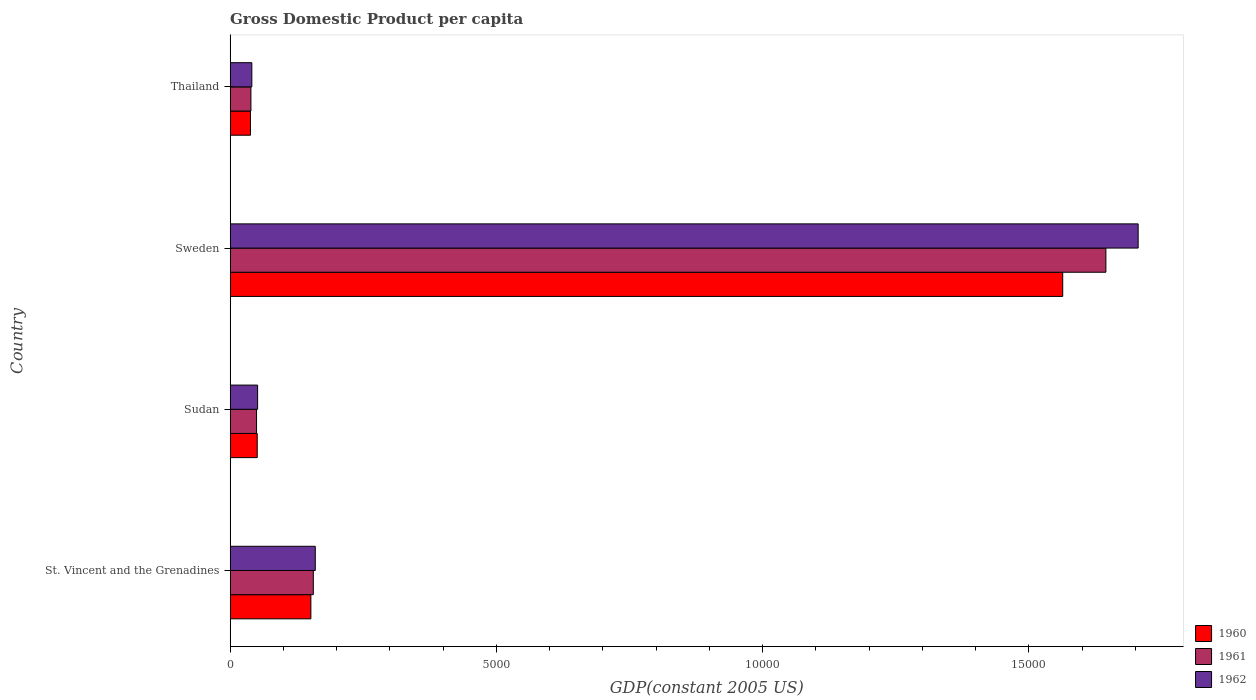How many groups of bars are there?
Give a very brief answer. 4. Are the number of bars per tick equal to the number of legend labels?
Your answer should be very brief. Yes. How many bars are there on the 1st tick from the top?
Keep it short and to the point. 3. How many bars are there on the 1st tick from the bottom?
Offer a terse response. 3. What is the label of the 2nd group of bars from the top?
Make the answer very short. Sweden. In how many cases, is the number of bars for a given country not equal to the number of legend labels?
Keep it short and to the point. 0. What is the GDP per capita in 1960 in Sweden?
Provide a short and direct response. 1.56e+04. Across all countries, what is the maximum GDP per capita in 1962?
Provide a short and direct response. 1.71e+04. Across all countries, what is the minimum GDP per capita in 1962?
Your answer should be very brief. 406.6. In which country was the GDP per capita in 1960 minimum?
Offer a terse response. Thailand. What is the total GDP per capita in 1962 in the graph?
Offer a very short reply. 1.96e+04. What is the difference between the GDP per capita in 1961 in Sudan and that in Sweden?
Offer a very short reply. -1.60e+04. What is the difference between the GDP per capita in 1960 in Thailand and the GDP per capita in 1961 in Sweden?
Make the answer very short. -1.61e+04. What is the average GDP per capita in 1961 per country?
Keep it short and to the point. 4722.79. What is the difference between the GDP per capita in 1961 and GDP per capita in 1962 in Sweden?
Your response must be concise. -606.08. What is the ratio of the GDP per capita in 1960 in Sudan to that in Thailand?
Your answer should be compact. 1.33. What is the difference between the highest and the second highest GDP per capita in 1961?
Provide a short and direct response. 1.49e+04. What is the difference between the highest and the lowest GDP per capita in 1960?
Offer a terse response. 1.53e+04. In how many countries, is the GDP per capita in 1962 greater than the average GDP per capita in 1962 taken over all countries?
Make the answer very short. 1. Is the sum of the GDP per capita in 1962 in Sudan and Thailand greater than the maximum GDP per capita in 1960 across all countries?
Offer a terse response. No. What does the 1st bar from the bottom in St. Vincent and the Grenadines represents?
Your answer should be very brief. 1960. Is it the case that in every country, the sum of the GDP per capita in 1962 and GDP per capita in 1960 is greater than the GDP per capita in 1961?
Offer a terse response. Yes. Does the graph contain any zero values?
Offer a very short reply. No. How are the legend labels stacked?
Ensure brevity in your answer.  Vertical. What is the title of the graph?
Provide a short and direct response. Gross Domestic Product per capita. Does "1996" appear as one of the legend labels in the graph?
Your response must be concise. No. What is the label or title of the X-axis?
Make the answer very short. GDP(constant 2005 US). What is the label or title of the Y-axis?
Your response must be concise. Country. What is the GDP(constant 2005 US) of 1960 in St. Vincent and the Grenadines?
Offer a very short reply. 1515.48. What is the GDP(constant 2005 US) of 1961 in St. Vincent and the Grenadines?
Keep it short and to the point. 1561.03. What is the GDP(constant 2005 US) of 1962 in St. Vincent and the Grenadines?
Your answer should be compact. 1598.04. What is the GDP(constant 2005 US) of 1960 in Sudan?
Your response must be concise. 507.97. What is the GDP(constant 2005 US) of 1961 in Sudan?
Keep it short and to the point. 494.94. What is the GDP(constant 2005 US) in 1962 in Sudan?
Provide a succinct answer. 515.24. What is the GDP(constant 2005 US) in 1960 in Sweden?
Your answer should be very brief. 1.56e+04. What is the GDP(constant 2005 US) of 1961 in Sweden?
Keep it short and to the point. 1.64e+04. What is the GDP(constant 2005 US) in 1962 in Sweden?
Provide a succinct answer. 1.71e+04. What is the GDP(constant 2005 US) of 1960 in Thailand?
Your answer should be compact. 380.85. What is the GDP(constant 2005 US) of 1961 in Thailand?
Your answer should be compact. 389.52. What is the GDP(constant 2005 US) of 1962 in Thailand?
Your answer should be compact. 406.6. Across all countries, what is the maximum GDP(constant 2005 US) of 1960?
Offer a very short reply. 1.56e+04. Across all countries, what is the maximum GDP(constant 2005 US) of 1961?
Offer a terse response. 1.64e+04. Across all countries, what is the maximum GDP(constant 2005 US) in 1962?
Provide a succinct answer. 1.71e+04. Across all countries, what is the minimum GDP(constant 2005 US) of 1960?
Provide a succinct answer. 380.85. Across all countries, what is the minimum GDP(constant 2005 US) of 1961?
Give a very brief answer. 389.52. Across all countries, what is the minimum GDP(constant 2005 US) in 1962?
Your answer should be very brief. 406.6. What is the total GDP(constant 2005 US) in 1960 in the graph?
Ensure brevity in your answer.  1.80e+04. What is the total GDP(constant 2005 US) in 1961 in the graph?
Make the answer very short. 1.89e+04. What is the total GDP(constant 2005 US) of 1962 in the graph?
Offer a very short reply. 1.96e+04. What is the difference between the GDP(constant 2005 US) of 1960 in St. Vincent and the Grenadines and that in Sudan?
Provide a succinct answer. 1007.51. What is the difference between the GDP(constant 2005 US) in 1961 in St. Vincent and the Grenadines and that in Sudan?
Provide a succinct answer. 1066.09. What is the difference between the GDP(constant 2005 US) in 1962 in St. Vincent and the Grenadines and that in Sudan?
Your answer should be compact. 1082.79. What is the difference between the GDP(constant 2005 US) in 1960 in St. Vincent and the Grenadines and that in Sweden?
Your answer should be compact. -1.41e+04. What is the difference between the GDP(constant 2005 US) in 1961 in St. Vincent and the Grenadines and that in Sweden?
Make the answer very short. -1.49e+04. What is the difference between the GDP(constant 2005 US) of 1962 in St. Vincent and the Grenadines and that in Sweden?
Keep it short and to the point. -1.55e+04. What is the difference between the GDP(constant 2005 US) of 1960 in St. Vincent and the Grenadines and that in Thailand?
Offer a very short reply. 1134.63. What is the difference between the GDP(constant 2005 US) of 1961 in St. Vincent and the Grenadines and that in Thailand?
Your answer should be very brief. 1171.51. What is the difference between the GDP(constant 2005 US) in 1962 in St. Vincent and the Grenadines and that in Thailand?
Provide a short and direct response. 1191.44. What is the difference between the GDP(constant 2005 US) in 1960 in Sudan and that in Sweden?
Your answer should be very brief. -1.51e+04. What is the difference between the GDP(constant 2005 US) of 1961 in Sudan and that in Sweden?
Provide a short and direct response. -1.60e+04. What is the difference between the GDP(constant 2005 US) in 1962 in Sudan and that in Sweden?
Ensure brevity in your answer.  -1.65e+04. What is the difference between the GDP(constant 2005 US) of 1960 in Sudan and that in Thailand?
Offer a very short reply. 127.12. What is the difference between the GDP(constant 2005 US) of 1961 in Sudan and that in Thailand?
Provide a succinct answer. 105.42. What is the difference between the GDP(constant 2005 US) in 1962 in Sudan and that in Thailand?
Offer a very short reply. 108.64. What is the difference between the GDP(constant 2005 US) in 1960 in Sweden and that in Thailand?
Provide a succinct answer. 1.53e+04. What is the difference between the GDP(constant 2005 US) in 1961 in Sweden and that in Thailand?
Your response must be concise. 1.61e+04. What is the difference between the GDP(constant 2005 US) of 1962 in Sweden and that in Thailand?
Provide a short and direct response. 1.66e+04. What is the difference between the GDP(constant 2005 US) of 1960 in St. Vincent and the Grenadines and the GDP(constant 2005 US) of 1961 in Sudan?
Provide a short and direct response. 1020.54. What is the difference between the GDP(constant 2005 US) in 1960 in St. Vincent and the Grenadines and the GDP(constant 2005 US) in 1962 in Sudan?
Give a very brief answer. 1000.24. What is the difference between the GDP(constant 2005 US) of 1961 in St. Vincent and the Grenadines and the GDP(constant 2005 US) of 1962 in Sudan?
Ensure brevity in your answer.  1045.78. What is the difference between the GDP(constant 2005 US) of 1960 in St. Vincent and the Grenadines and the GDP(constant 2005 US) of 1961 in Sweden?
Offer a very short reply. -1.49e+04. What is the difference between the GDP(constant 2005 US) of 1960 in St. Vincent and the Grenadines and the GDP(constant 2005 US) of 1962 in Sweden?
Keep it short and to the point. -1.55e+04. What is the difference between the GDP(constant 2005 US) of 1961 in St. Vincent and the Grenadines and the GDP(constant 2005 US) of 1962 in Sweden?
Your answer should be compact. -1.55e+04. What is the difference between the GDP(constant 2005 US) in 1960 in St. Vincent and the Grenadines and the GDP(constant 2005 US) in 1961 in Thailand?
Provide a short and direct response. 1125.96. What is the difference between the GDP(constant 2005 US) in 1960 in St. Vincent and the Grenadines and the GDP(constant 2005 US) in 1962 in Thailand?
Keep it short and to the point. 1108.88. What is the difference between the GDP(constant 2005 US) of 1961 in St. Vincent and the Grenadines and the GDP(constant 2005 US) of 1962 in Thailand?
Keep it short and to the point. 1154.43. What is the difference between the GDP(constant 2005 US) in 1960 in Sudan and the GDP(constant 2005 US) in 1961 in Sweden?
Give a very brief answer. -1.59e+04. What is the difference between the GDP(constant 2005 US) of 1960 in Sudan and the GDP(constant 2005 US) of 1962 in Sweden?
Your response must be concise. -1.65e+04. What is the difference between the GDP(constant 2005 US) of 1961 in Sudan and the GDP(constant 2005 US) of 1962 in Sweden?
Provide a succinct answer. -1.66e+04. What is the difference between the GDP(constant 2005 US) in 1960 in Sudan and the GDP(constant 2005 US) in 1961 in Thailand?
Offer a terse response. 118.46. What is the difference between the GDP(constant 2005 US) of 1960 in Sudan and the GDP(constant 2005 US) of 1962 in Thailand?
Offer a very short reply. 101.38. What is the difference between the GDP(constant 2005 US) in 1961 in Sudan and the GDP(constant 2005 US) in 1962 in Thailand?
Your answer should be very brief. 88.34. What is the difference between the GDP(constant 2005 US) in 1960 in Sweden and the GDP(constant 2005 US) in 1961 in Thailand?
Keep it short and to the point. 1.52e+04. What is the difference between the GDP(constant 2005 US) of 1960 in Sweden and the GDP(constant 2005 US) of 1962 in Thailand?
Offer a terse response. 1.52e+04. What is the difference between the GDP(constant 2005 US) of 1961 in Sweden and the GDP(constant 2005 US) of 1962 in Thailand?
Offer a terse response. 1.60e+04. What is the average GDP(constant 2005 US) in 1960 per country?
Give a very brief answer. 4509.84. What is the average GDP(constant 2005 US) in 1961 per country?
Offer a very short reply. 4722.79. What is the average GDP(constant 2005 US) in 1962 per country?
Your response must be concise. 4892.91. What is the difference between the GDP(constant 2005 US) in 1960 and GDP(constant 2005 US) in 1961 in St. Vincent and the Grenadines?
Your answer should be very brief. -45.55. What is the difference between the GDP(constant 2005 US) in 1960 and GDP(constant 2005 US) in 1962 in St. Vincent and the Grenadines?
Make the answer very short. -82.55. What is the difference between the GDP(constant 2005 US) of 1961 and GDP(constant 2005 US) of 1962 in St. Vincent and the Grenadines?
Offer a terse response. -37.01. What is the difference between the GDP(constant 2005 US) in 1960 and GDP(constant 2005 US) in 1961 in Sudan?
Provide a short and direct response. 13.04. What is the difference between the GDP(constant 2005 US) in 1960 and GDP(constant 2005 US) in 1962 in Sudan?
Make the answer very short. -7.27. What is the difference between the GDP(constant 2005 US) in 1961 and GDP(constant 2005 US) in 1962 in Sudan?
Provide a succinct answer. -20.31. What is the difference between the GDP(constant 2005 US) of 1960 and GDP(constant 2005 US) of 1961 in Sweden?
Give a very brief answer. -810.66. What is the difference between the GDP(constant 2005 US) of 1960 and GDP(constant 2005 US) of 1962 in Sweden?
Give a very brief answer. -1416.73. What is the difference between the GDP(constant 2005 US) in 1961 and GDP(constant 2005 US) in 1962 in Sweden?
Keep it short and to the point. -606.08. What is the difference between the GDP(constant 2005 US) in 1960 and GDP(constant 2005 US) in 1961 in Thailand?
Offer a terse response. -8.66. What is the difference between the GDP(constant 2005 US) in 1960 and GDP(constant 2005 US) in 1962 in Thailand?
Make the answer very short. -25.75. What is the difference between the GDP(constant 2005 US) in 1961 and GDP(constant 2005 US) in 1962 in Thailand?
Provide a succinct answer. -17.08. What is the ratio of the GDP(constant 2005 US) of 1960 in St. Vincent and the Grenadines to that in Sudan?
Your answer should be compact. 2.98. What is the ratio of the GDP(constant 2005 US) in 1961 in St. Vincent and the Grenadines to that in Sudan?
Provide a succinct answer. 3.15. What is the ratio of the GDP(constant 2005 US) in 1962 in St. Vincent and the Grenadines to that in Sudan?
Your response must be concise. 3.1. What is the ratio of the GDP(constant 2005 US) of 1960 in St. Vincent and the Grenadines to that in Sweden?
Make the answer very short. 0.1. What is the ratio of the GDP(constant 2005 US) in 1961 in St. Vincent and the Grenadines to that in Sweden?
Give a very brief answer. 0.09. What is the ratio of the GDP(constant 2005 US) of 1962 in St. Vincent and the Grenadines to that in Sweden?
Offer a very short reply. 0.09. What is the ratio of the GDP(constant 2005 US) in 1960 in St. Vincent and the Grenadines to that in Thailand?
Your response must be concise. 3.98. What is the ratio of the GDP(constant 2005 US) of 1961 in St. Vincent and the Grenadines to that in Thailand?
Offer a very short reply. 4.01. What is the ratio of the GDP(constant 2005 US) of 1962 in St. Vincent and the Grenadines to that in Thailand?
Your answer should be very brief. 3.93. What is the ratio of the GDP(constant 2005 US) of 1960 in Sudan to that in Sweden?
Offer a terse response. 0.03. What is the ratio of the GDP(constant 2005 US) of 1961 in Sudan to that in Sweden?
Your answer should be compact. 0.03. What is the ratio of the GDP(constant 2005 US) in 1962 in Sudan to that in Sweden?
Keep it short and to the point. 0.03. What is the ratio of the GDP(constant 2005 US) of 1960 in Sudan to that in Thailand?
Make the answer very short. 1.33. What is the ratio of the GDP(constant 2005 US) of 1961 in Sudan to that in Thailand?
Your response must be concise. 1.27. What is the ratio of the GDP(constant 2005 US) of 1962 in Sudan to that in Thailand?
Offer a very short reply. 1.27. What is the ratio of the GDP(constant 2005 US) of 1960 in Sweden to that in Thailand?
Your response must be concise. 41.05. What is the ratio of the GDP(constant 2005 US) of 1961 in Sweden to that in Thailand?
Offer a terse response. 42.22. What is the ratio of the GDP(constant 2005 US) in 1962 in Sweden to that in Thailand?
Offer a very short reply. 41.94. What is the difference between the highest and the second highest GDP(constant 2005 US) in 1960?
Provide a succinct answer. 1.41e+04. What is the difference between the highest and the second highest GDP(constant 2005 US) of 1961?
Your answer should be very brief. 1.49e+04. What is the difference between the highest and the second highest GDP(constant 2005 US) in 1962?
Your answer should be compact. 1.55e+04. What is the difference between the highest and the lowest GDP(constant 2005 US) in 1960?
Make the answer very short. 1.53e+04. What is the difference between the highest and the lowest GDP(constant 2005 US) in 1961?
Offer a terse response. 1.61e+04. What is the difference between the highest and the lowest GDP(constant 2005 US) of 1962?
Make the answer very short. 1.66e+04. 